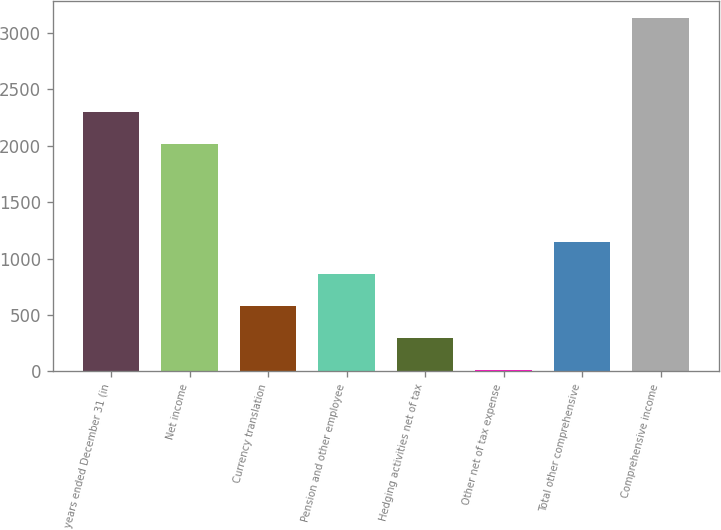Convert chart. <chart><loc_0><loc_0><loc_500><loc_500><bar_chart><fcel>years ended December 31 (in<fcel>Net income<fcel>Currency translation<fcel>Pension and other employee<fcel>Hedging activities net of tax<fcel>Other net of tax expense<fcel>Total other comprehensive<fcel>Comprehensive income<nl><fcel>2295.7<fcel>2012<fcel>576.4<fcel>860.1<fcel>292.7<fcel>9<fcel>1143.8<fcel>3129.7<nl></chart> 